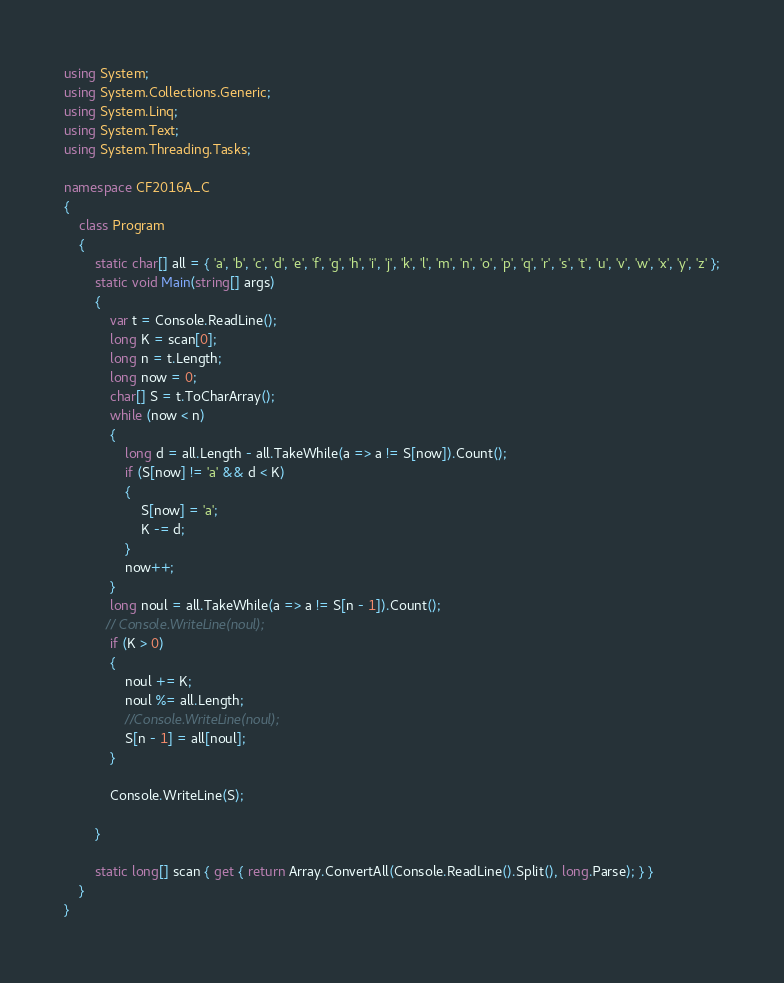<code> <loc_0><loc_0><loc_500><loc_500><_C#_>using System;
using System.Collections.Generic;
using System.Linq;
using System.Text;
using System.Threading.Tasks;

namespace CF2016A_C
{
    class Program
    {
        static char[] all = { 'a', 'b', 'c', 'd', 'e', 'f', 'g', 'h', 'i', 'j', 'k', 'l', 'm', 'n', 'o', 'p', 'q', 'r', 's', 't', 'u', 'v', 'w', 'x', 'y', 'z' };
        static void Main(string[] args)
        {
            var t = Console.ReadLine();
            long K = scan[0];
            long n = t.Length;
            long now = 0;
            char[] S = t.ToCharArray();
            while (now < n)
            {
                long d = all.Length - all.TakeWhile(a => a != S[now]).Count();
                if (S[now] != 'a' && d < K)
                {
                    S[now] = 'a';
                    K -= d;
                }
                now++;
            }
            long noul = all.TakeWhile(a => a != S[n - 1]).Count();
           // Console.WriteLine(noul);
            if (K > 0)
            {
                noul += K;
                noul %= all.Length;
                //Console.WriteLine(noul);
                S[n - 1] = all[noul];
            }

            Console.WriteLine(S);

        }

        static long[] scan { get { return Array.ConvertAll(Console.ReadLine().Split(), long.Parse); } }
    }
}
</code> 